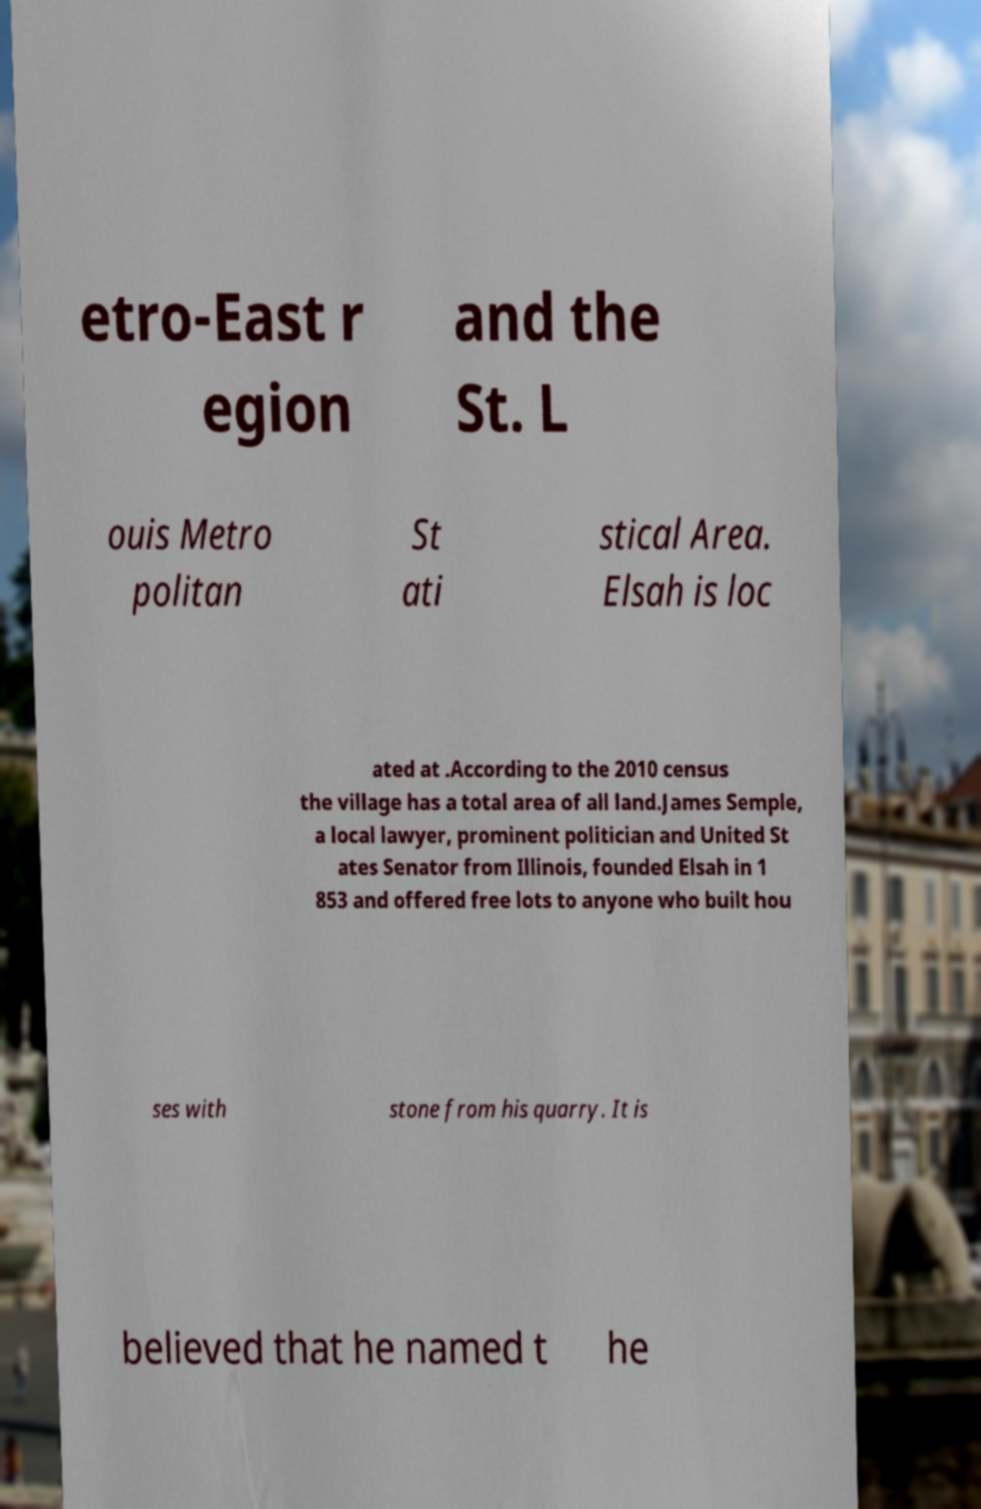Can you accurately transcribe the text from the provided image for me? etro-East r egion and the St. L ouis Metro politan St ati stical Area. Elsah is loc ated at .According to the 2010 census the village has a total area of all land.James Semple, a local lawyer, prominent politician and United St ates Senator from Illinois, founded Elsah in 1 853 and offered free lots to anyone who built hou ses with stone from his quarry. It is believed that he named t he 